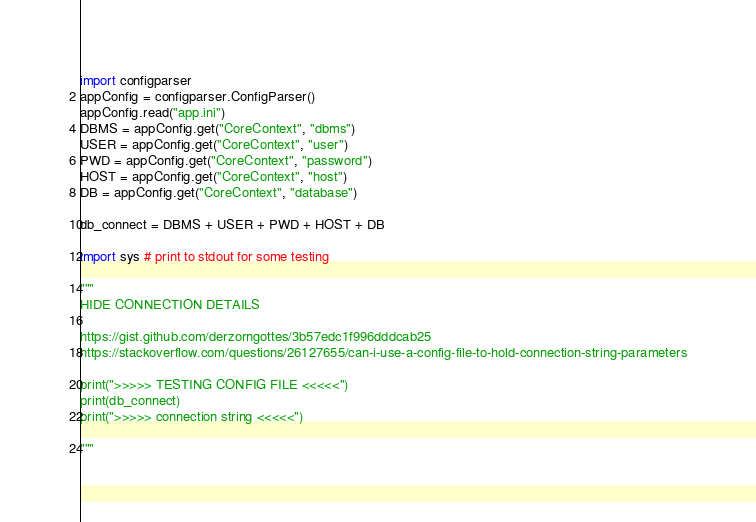Convert code to text. <code><loc_0><loc_0><loc_500><loc_500><_Python_>import configparser
appConfig = configparser.ConfigParser()
appConfig.read("app.ini")
DBMS = appConfig.get("CoreContext", "dbms")
USER = appConfig.get("CoreContext", "user")
PWD = appConfig.get("CoreContext", "password")
HOST = appConfig.get("CoreContext", "host")
DB = appConfig.get("CoreContext", "database")

db_connect = DBMS + USER + PWD + HOST + DB

import sys # print to stdout for some testing

"""
HIDE CONNECTION DETAILS

https://gist.github.com/derzorngottes/3b57edc1f996dddcab25
https://stackoverflow.com/questions/26127655/can-i-use-a-config-file-to-hold-connection-string-parameters

print(">>>>> TESTING CONFIG FILE <<<<<")
print(db_connect)
print(">>>>> connection string <<<<<")

"""
</code> 